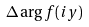<formula> <loc_0><loc_0><loc_500><loc_500>\Delta \arg f ( i y )</formula> 